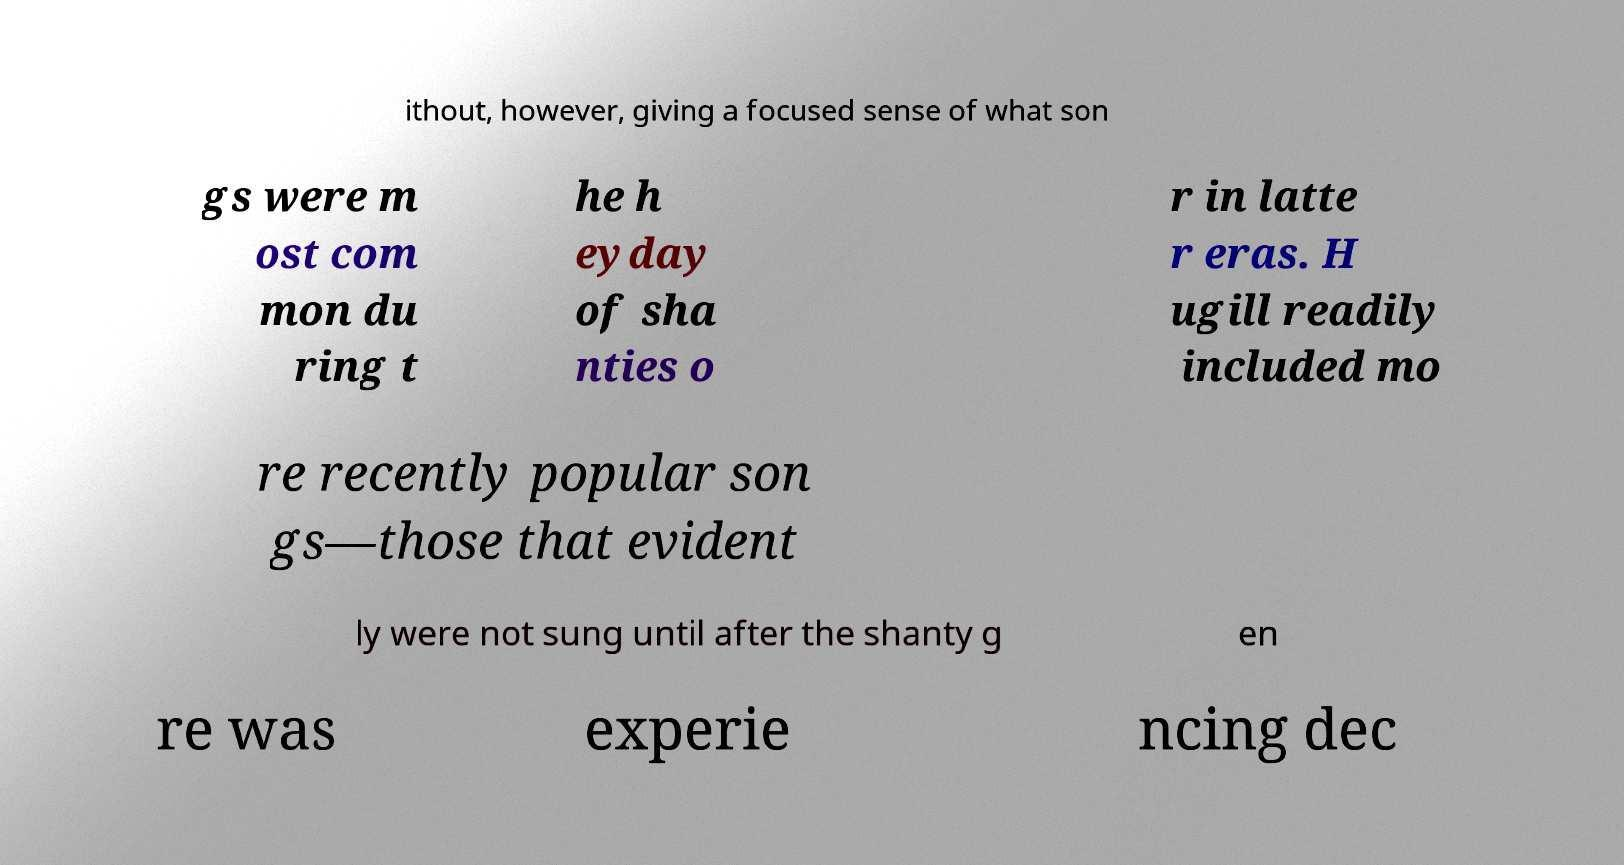What messages or text are displayed in this image? I need them in a readable, typed format. ithout, however, giving a focused sense of what son gs were m ost com mon du ring t he h eyday of sha nties o r in latte r eras. H ugill readily included mo re recently popular son gs—those that evident ly were not sung until after the shanty g en re was experie ncing dec 